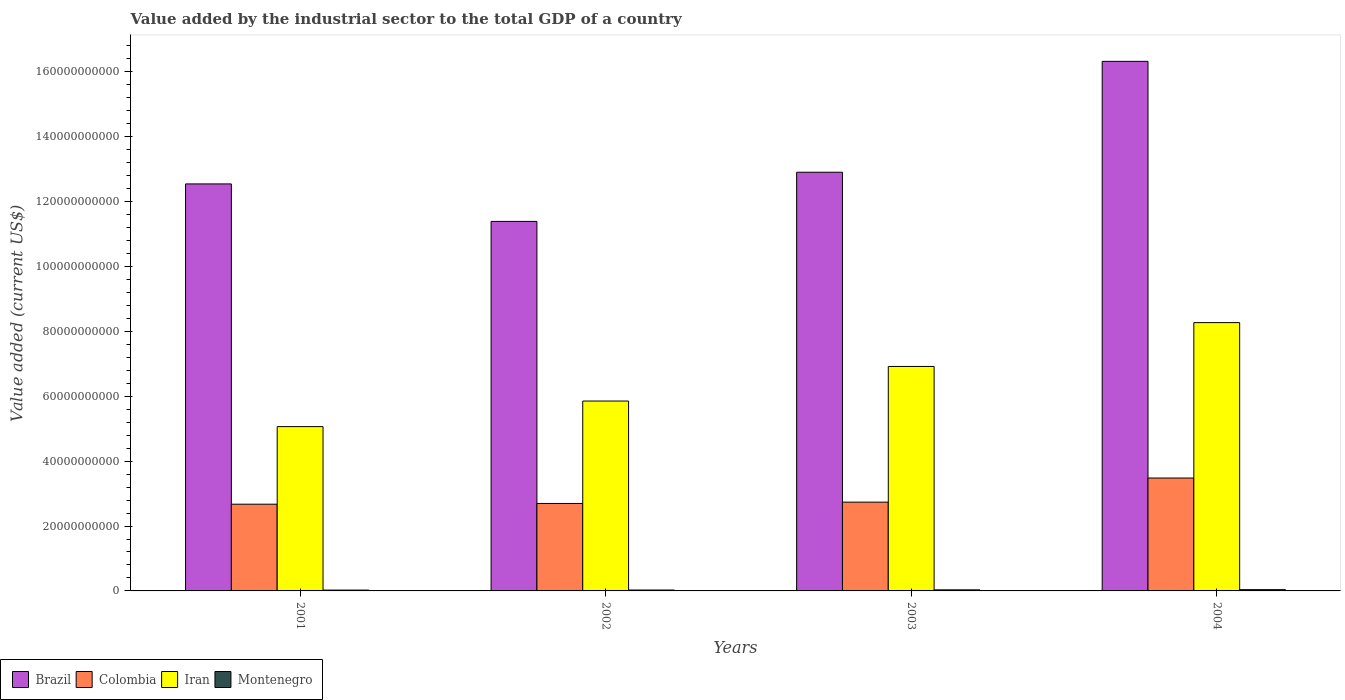How many different coloured bars are there?
Provide a short and direct response. 4. How many groups of bars are there?
Give a very brief answer. 4. Are the number of bars per tick equal to the number of legend labels?
Your answer should be compact. Yes. How many bars are there on the 1st tick from the left?
Give a very brief answer. 4. What is the label of the 3rd group of bars from the left?
Your answer should be very brief. 2003. What is the value added by the industrial sector to the total GDP in Iran in 2002?
Keep it short and to the point. 5.85e+1. Across all years, what is the maximum value added by the industrial sector to the total GDP in Montenegro?
Give a very brief answer. 3.93e+08. Across all years, what is the minimum value added by the industrial sector to the total GDP in Montenegro?
Give a very brief answer. 2.59e+08. In which year was the value added by the industrial sector to the total GDP in Montenegro maximum?
Your response must be concise. 2004. In which year was the value added by the industrial sector to the total GDP in Brazil minimum?
Your answer should be very brief. 2002. What is the total value added by the industrial sector to the total GDP in Colombia in the graph?
Offer a terse response. 1.16e+11. What is the difference between the value added by the industrial sector to the total GDP in Iran in 2001 and that in 2002?
Offer a very short reply. -7.88e+09. What is the difference between the value added by the industrial sector to the total GDP in Iran in 2003 and the value added by the industrial sector to the total GDP in Brazil in 2002?
Make the answer very short. -4.47e+1. What is the average value added by the industrial sector to the total GDP in Montenegro per year?
Your response must be concise. 3.15e+08. In the year 2004, what is the difference between the value added by the industrial sector to the total GDP in Montenegro and value added by the industrial sector to the total GDP in Colombia?
Your answer should be very brief. -3.44e+1. In how many years, is the value added by the industrial sector to the total GDP in Montenegro greater than 140000000000 US$?
Ensure brevity in your answer.  0. What is the ratio of the value added by the industrial sector to the total GDP in Colombia in 2001 to that in 2004?
Keep it short and to the point. 0.77. Is the difference between the value added by the industrial sector to the total GDP in Montenegro in 2001 and 2002 greater than the difference between the value added by the industrial sector to the total GDP in Colombia in 2001 and 2002?
Your response must be concise. Yes. What is the difference between the highest and the second highest value added by the industrial sector to the total GDP in Iran?
Provide a short and direct response. 1.35e+1. What is the difference between the highest and the lowest value added by the industrial sector to the total GDP in Colombia?
Offer a very short reply. 8.07e+09. In how many years, is the value added by the industrial sector to the total GDP in Montenegro greater than the average value added by the industrial sector to the total GDP in Montenegro taken over all years?
Provide a short and direct response. 2. What does the 2nd bar from the left in 2004 represents?
Keep it short and to the point. Colombia. What does the 2nd bar from the right in 2003 represents?
Your answer should be compact. Iran. Is it the case that in every year, the sum of the value added by the industrial sector to the total GDP in Iran and value added by the industrial sector to the total GDP in Colombia is greater than the value added by the industrial sector to the total GDP in Montenegro?
Ensure brevity in your answer.  Yes. How many bars are there?
Offer a terse response. 16. Are all the bars in the graph horizontal?
Provide a short and direct response. No. How many legend labels are there?
Your answer should be compact. 4. How are the legend labels stacked?
Ensure brevity in your answer.  Horizontal. What is the title of the graph?
Your response must be concise. Value added by the industrial sector to the total GDP of a country. Does "Marshall Islands" appear as one of the legend labels in the graph?
Offer a terse response. No. What is the label or title of the X-axis?
Your response must be concise. Years. What is the label or title of the Y-axis?
Provide a short and direct response. Value added (current US$). What is the Value added (current US$) in Brazil in 2001?
Provide a short and direct response. 1.25e+11. What is the Value added (current US$) in Colombia in 2001?
Offer a terse response. 2.67e+1. What is the Value added (current US$) of Iran in 2001?
Ensure brevity in your answer.  5.06e+1. What is the Value added (current US$) of Montenegro in 2001?
Offer a very short reply. 2.59e+08. What is the Value added (current US$) of Brazil in 2002?
Provide a succinct answer. 1.14e+11. What is the Value added (current US$) in Colombia in 2002?
Offer a very short reply. 2.70e+1. What is the Value added (current US$) in Iran in 2002?
Your answer should be very brief. 5.85e+1. What is the Value added (current US$) in Montenegro in 2002?
Provide a short and direct response. 2.77e+08. What is the Value added (current US$) in Brazil in 2003?
Give a very brief answer. 1.29e+11. What is the Value added (current US$) of Colombia in 2003?
Provide a short and direct response. 2.74e+1. What is the Value added (current US$) of Iran in 2003?
Provide a short and direct response. 6.92e+1. What is the Value added (current US$) in Montenegro in 2003?
Your response must be concise. 3.30e+08. What is the Value added (current US$) in Brazil in 2004?
Keep it short and to the point. 1.63e+11. What is the Value added (current US$) in Colombia in 2004?
Give a very brief answer. 3.48e+1. What is the Value added (current US$) in Iran in 2004?
Give a very brief answer. 8.27e+1. What is the Value added (current US$) in Montenegro in 2004?
Make the answer very short. 3.93e+08. Across all years, what is the maximum Value added (current US$) in Brazil?
Make the answer very short. 1.63e+11. Across all years, what is the maximum Value added (current US$) of Colombia?
Ensure brevity in your answer.  3.48e+1. Across all years, what is the maximum Value added (current US$) of Iran?
Offer a very short reply. 8.27e+1. Across all years, what is the maximum Value added (current US$) in Montenegro?
Your answer should be compact. 3.93e+08. Across all years, what is the minimum Value added (current US$) in Brazil?
Make the answer very short. 1.14e+11. Across all years, what is the minimum Value added (current US$) of Colombia?
Provide a succinct answer. 2.67e+1. Across all years, what is the minimum Value added (current US$) in Iran?
Provide a short and direct response. 5.06e+1. Across all years, what is the minimum Value added (current US$) in Montenegro?
Make the answer very short. 2.59e+08. What is the total Value added (current US$) of Brazil in the graph?
Provide a short and direct response. 5.32e+11. What is the total Value added (current US$) of Colombia in the graph?
Provide a succinct answer. 1.16e+11. What is the total Value added (current US$) in Iran in the graph?
Your answer should be compact. 2.61e+11. What is the total Value added (current US$) of Montenegro in the graph?
Ensure brevity in your answer.  1.26e+09. What is the difference between the Value added (current US$) of Brazil in 2001 and that in 2002?
Offer a very short reply. 1.16e+1. What is the difference between the Value added (current US$) of Colombia in 2001 and that in 2002?
Provide a short and direct response. -2.26e+08. What is the difference between the Value added (current US$) in Iran in 2001 and that in 2002?
Offer a terse response. -7.88e+09. What is the difference between the Value added (current US$) of Montenegro in 2001 and that in 2002?
Provide a short and direct response. -1.86e+07. What is the difference between the Value added (current US$) in Brazil in 2001 and that in 2003?
Provide a short and direct response. -3.60e+09. What is the difference between the Value added (current US$) of Colombia in 2001 and that in 2003?
Provide a succinct answer. -6.34e+08. What is the difference between the Value added (current US$) of Iran in 2001 and that in 2003?
Offer a terse response. -1.85e+1. What is the difference between the Value added (current US$) in Montenegro in 2001 and that in 2003?
Offer a terse response. -7.13e+07. What is the difference between the Value added (current US$) of Brazil in 2001 and that in 2004?
Provide a succinct answer. -3.78e+1. What is the difference between the Value added (current US$) of Colombia in 2001 and that in 2004?
Your response must be concise. -8.07e+09. What is the difference between the Value added (current US$) of Iran in 2001 and that in 2004?
Offer a very short reply. -3.21e+1. What is the difference between the Value added (current US$) of Montenegro in 2001 and that in 2004?
Offer a very short reply. -1.35e+08. What is the difference between the Value added (current US$) of Brazil in 2002 and that in 2003?
Provide a short and direct response. -1.52e+1. What is the difference between the Value added (current US$) of Colombia in 2002 and that in 2003?
Provide a short and direct response. -4.07e+08. What is the difference between the Value added (current US$) of Iran in 2002 and that in 2003?
Give a very brief answer. -1.07e+1. What is the difference between the Value added (current US$) in Montenegro in 2002 and that in 2003?
Offer a terse response. -5.26e+07. What is the difference between the Value added (current US$) in Brazil in 2002 and that in 2004?
Keep it short and to the point. -4.93e+1. What is the difference between the Value added (current US$) of Colombia in 2002 and that in 2004?
Ensure brevity in your answer.  -7.84e+09. What is the difference between the Value added (current US$) in Iran in 2002 and that in 2004?
Ensure brevity in your answer.  -2.42e+1. What is the difference between the Value added (current US$) of Montenegro in 2002 and that in 2004?
Provide a short and direct response. -1.16e+08. What is the difference between the Value added (current US$) in Brazil in 2003 and that in 2004?
Offer a terse response. -3.42e+1. What is the difference between the Value added (current US$) of Colombia in 2003 and that in 2004?
Give a very brief answer. -7.43e+09. What is the difference between the Value added (current US$) in Iran in 2003 and that in 2004?
Your answer should be compact. -1.35e+1. What is the difference between the Value added (current US$) of Montenegro in 2003 and that in 2004?
Your answer should be compact. -6.33e+07. What is the difference between the Value added (current US$) of Brazil in 2001 and the Value added (current US$) of Colombia in 2002?
Your answer should be very brief. 9.85e+1. What is the difference between the Value added (current US$) of Brazil in 2001 and the Value added (current US$) of Iran in 2002?
Make the answer very short. 6.69e+1. What is the difference between the Value added (current US$) in Brazil in 2001 and the Value added (current US$) in Montenegro in 2002?
Provide a short and direct response. 1.25e+11. What is the difference between the Value added (current US$) in Colombia in 2001 and the Value added (current US$) in Iran in 2002?
Keep it short and to the point. -3.18e+1. What is the difference between the Value added (current US$) in Colombia in 2001 and the Value added (current US$) in Montenegro in 2002?
Offer a very short reply. 2.65e+1. What is the difference between the Value added (current US$) of Iran in 2001 and the Value added (current US$) of Montenegro in 2002?
Offer a terse response. 5.04e+1. What is the difference between the Value added (current US$) of Brazil in 2001 and the Value added (current US$) of Colombia in 2003?
Offer a terse response. 9.81e+1. What is the difference between the Value added (current US$) in Brazil in 2001 and the Value added (current US$) in Iran in 2003?
Offer a terse response. 5.63e+1. What is the difference between the Value added (current US$) of Brazil in 2001 and the Value added (current US$) of Montenegro in 2003?
Offer a very short reply. 1.25e+11. What is the difference between the Value added (current US$) of Colombia in 2001 and the Value added (current US$) of Iran in 2003?
Keep it short and to the point. -4.25e+1. What is the difference between the Value added (current US$) in Colombia in 2001 and the Value added (current US$) in Montenegro in 2003?
Ensure brevity in your answer.  2.64e+1. What is the difference between the Value added (current US$) of Iran in 2001 and the Value added (current US$) of Montenegro in 2003?
Keep it short and to the point. 5.03e+1. What is the difference between the Value added (current US$) in Brazil in 2001 and the Value added (current US$) in Colombia in 2004?
Keep it short and to the point. 9.07e+1. What is the difference between the Value added (current US$) of Brazil in 2001 and the Value added (current US$) of Iran in 2004?
Your answer should be compact. 4.28e+1. What is the difference between the Value added (current US$) of Brazil in 2001 and the Value added (current US$) of Montenegro in 2004?
Provide a short and direct response. 1.25e+11. What is the difference between the Value added (current US$) of Colombia in 2001 and the Value added (current US$) of Iran in 2004?
Provide a short and direct response. -5.60e+1. What is the difference between the Value added (current US$) of Colombia in 2001 and the Value added (current US$) of Montenegro in 2004?
Ensure brevity in your answer.  2.63e+1. What is the difference between the Value added (current US$) of Iran in 2001 and the Value added (current US$) of Montenegro in 2004?
Offer a very short reply. 5.03e+1. What is the difference between the Value added (current US$) in Brazil in 2002 and the Value added (current US$) in Colombia in 2003?
Ensure brevity in your answer.  8.65e+1. What is the difference between the Value added (current US$) of Brazil in 2002 and the Value added (current US$) of Iran in 2003?
Provide a succinct answer. 4.47e+1. What is the difference between the Value added (current US$) of Brazil in 2002 and the Value added (current US$) of Montenegro in 2003?
Provide a succinct answer. 1.14e+11. What is the difference between the Value added (current US$) of Colombia in 2002 and the Value added (current US$) of Iran in 2003?
Offer a very short reply. -4.22e+1. What is the difference between the Value added (current US$) of Colombia in 2002 and the Value added (current US$) of Montenegro in 2003?
Make the answer very short. 2.66e+1. What is the difference between the Value added (current US$) of Iran in 2002 and the Value added (current US$) of Montenegro in 2003?
Your answer should be compact. 5.82e+1. What is the difference between the Value added (current US$) in Brazil in 2002 and the Value added (current US$) in Colombia in 2004?
Make the answer very short. 7.91e+1. What is the difference between the Value added (current US$) in Brazil in 2002 and the Value added (current US$) in Iran in 2004?
Your response must be concise. 3.12e+1. What is the difference between the Value added (current US$) of Brazil in 2002 and the Value added (current US$) of Montenegro in 2004?
Offer a very short reply. 1.14e+11. What is the difference between the Value added (current US$) of Colombia in 2002 and the Value added (current US$) of Iran in 2004?
Ensure brevity in your answer.  -5.57e+1. What is the difference between the Value added (current US$) in Colombia in 2002 and the Value added (current US$) in Montenegro in 2004?
Offer a terse response. 2.66e+1. What is the difference between the Value added (current US$) in Iran in 2002 and the Value added (current US$) in Montenegro in 2004?
Offer a very short reply. 5.81e+1. What is the difference between the Value added (current US$) in Brazil in 2003 and the Value added (current US$) in Colombia in 2004?
Provide a short and direct response. 9.43e+1. What is the difference between the Value added (current US$) of Brazil in 2003 and the Value added (current US$) of Iran in 2004?
Your answer should be very brief. 4.64e+1. What is the difference between the Value added (current US$) in Brazil in 2003 and the Value added (current US$) in Montenegro in 2004?
Ensure brevity in your answer.  1.29e+11. What is the difference between the Value added (current US$) of Colombia in 2003 and the Value added (current US$) of Iran in 2004?
Your response must be concise. -5.53e+1. What is the difference between the Value added (current US$) of Colombia in 2003 and the Value added (current US$) of Montenegro in 2004?
Make the answer very short. 2.70e+1. What is the difference between the Value added (current US$) of Iran in 2003 and the Value added (current US$) of Montenegro in 2004?
Keep it short and to the point. 6.88e+1. What is the average Value added (current US$) of Brazil per year?
Offer a terse response. 1.33e+11. What is the average Value added (current US$) of Colombia per year?
Provide a short and direct response. 2.90e+1. What is the average Value added (current US$) of Iran per year?
Your answer should be very brief. 6.53e+1. What is the average Value added (current US$) in Montenegro per year?
Your response must be concise. 3.15e+08. In the year 2001, what is the difference between the Value added (current US$) in Brazil and Value added (current US$) in Colombia?
Offer a very short reply. 9.87e+1. In the year 2001, what is the difference between the Value added (current US$) in Brazil and Value added (current US$) in Iran?
Offer a terse response. 7.48e+1. In the year 2001, what is the difference between the Value added (current US$) of Brazil and Value added (current US$) of Montenegro?
Your answer should be very brief. 1.25e+11. In the year 2001, what is the difference between the Value added (current US$) of Colombia and Value added (current US$) of Iran?
Provide a succinct answer. -2.39e+1. In the year 2001, what is the difference between the Value added (current US$) in Colombia and Value added (current US$) in Montenegro?
Your answer should be very brief. 2.65e+1. In the year 2001, what is the difference between the Value added (current US$) in Iran and Value added (current US$) in Montenegro?
Offer a terse response. 5.04e+1. In the year 2002, what is the difference between the Value added (current US$) in Brazil and Value added (current US$) in Colombia?
Provide a succinct answer. 8.69e+1. In the year 2002, what is the difference between the Value added (current US$) in Brazil and Value added (current US$) in Iran?
Ensure brevity in your answer.  5.54e+1. In the year 2002, what is the difference between the Value added (current US$) in Brazil and Value added (current US$) in Montenegro?
Provide a short and direct response. 1.14e+11. In the year 2002, what is the difference between the Value added (current US$) of Colombia and Value added (current US$) of Iran?
Offer a very short reply. -3.16e+1. In the year 2002, what is the difference between the Value added (current US$) in Colombia and Value added (current US$) in Montenegro?
Provide a short and direct response. 2.67e+1. In the year 2002, what is the difference between the Value added (current US$) of Iran and Value added (current US$) of Montenegro?
Ensure brevity in your answer.  5.83e+1. In the year 2003, what is the difference between the Value added (current US$) of Brazil and Value added (current US$) of Colombia?
Give a very brief answer. 1.02e+11. In the year 2003, what is the difference between the Value added (current US$) in Brazil and Value added (current US$) in Iran?
Keep it short and to the point. 5.99e+1. In the year 2003, what is the difference between the Value added (current US$) of Brazil and Value added (current US$) of Montenegro?
Keep it short and to the point. 1.29e+11. In the year 2003, what is the difference between the Value added (current US$) of Colombia and Value added (current US$) of Iran?
Make the answer very short. -4.18e+1. In the year 2003, what is the difference between the Value added (current US$) in Colombia and Value added (current US$) in Montenegro?
Your answer should be compact. 2.70e+1. In the year 2003, what is the difference between the Value added (current US$) in Iran and Value added (current US$) in Montenegro?
Ensure brevity in your answer.  6.89e+1. In the year 2004, what is the difference between the Value added (current US$) of Brazil and Value added (current US$) of Colombia?
Your answer should be very brief. 1.28e+11. In the year 2004, what is the difference between the Value added (current US$) of Brazil and Value added (current US$) of Iran?
Offer a terse response. 8.05e+1. In the year 2004, what is the difference between the Value added (current US$) of Brazil and Value added (current US$) of Montenegro?
Keep it short and to the point. 1.63e+11. In the year 2004, what is the difference between the Value added (current US$) in Colombia and Value added (current US$) in Iran?
Give a very brief answer. -4.79e+1. In the year 2004, what is the difference between the Value added (current US$) in Colombia and Value added (current US$) in Montenegro?
Keep it short and to the point. 3.44e+1. In the year 2004, what is the difference between the Value added (current US$) in Iran and Value added (current US$) in Montenegro?
Your answer should be very brief. 8.23e+1. What is the ratio of the Value added (current US$) of Brazil in 2001 to that in 2002?
Give a very brief answer. 1.1. What is the ratio of the Value added (current US$) in Iran in 2001 to that in 2002?
Keep it short and to the point. 0.87. What is the ratio of the Value added (current US$) of Montenegro in 2001 to that in 2002?
Provide a short and direct response. 0.93. What is the ratio of the Value added (current US$) in Brazil in 2001 to that in 2003?
Your response must be concise. 0.97. What is the ratio of the Value added (current US$) in Colombia in 2001 to that in 2003?
Your response must be concise. 0.98. What is the ratio of the Value added (current US$) of Iran in 2001 to that in 2003?
Keep it short and to the point. 0.73. What is the ratio of the Value added (current US$) in Montenegro in 2001 to that in 2003?
Your answer should be very brief. 0.78. What is the ratio of the Value added (current US$) of Brazil in 2001 to that in 2004?
Give a very brief answer. 0.77. What is the ratio of the Value added (current US$) in Colombia in 2001 to that in 2004?
Your answer should be very brief. 0.77. What is the ratio of the Value added (current US$) of Iran in 2001 to that in 2004?
Make the answer very short. 0.61. What is the ratio of the Value added (current US$) in Montenegro in 2001 to that in 2004?
Ensure brevity in your answer.  0.66. What is the ratio of the Value added (current US$) in Brazil in 2002 to that in 2003?
Your answer should be very brief. 0.88. What is the ratio of the Value added (current US$) of Colombia in 2002 to that in 2003?
Your answer should be compact. 0.99. What is the ratio of the Value added (current US$) of Iran in 2002 to that in 2003?
Make the answer very short. 0.85. What is the ratio of the Value added (current US$) in Montenegro in 2002 to that in 2003?
Offer a terse response. 0.84. What is the ratio of the Value added (current US$) of Brazil in 2002 to that in 2004?
Your answer should be compact. 0.7. What is the ratio of the Value added (current US$) of Colombia in 2002 to that in 2004?
Ensure brevity in your answer.  0.77. What is the ratio of the Value added (current US$) in Iran in 2002 to that in 2004?
Provide a succinct answer. 0.71. What is the ratio of the Value added (current US$) in Montenegro in 2002 to that in 2004?
Your answer should be compact. 0.71. What is the ratio of the Value added (current US$) in Brazil in 2003 to that in 2004?
Make the answer very short. 0.79. What is the ratio of the Value added (current US$) of Colombia in 2003 to that in 2004?
Your answer should be very brief. 0.79. What is the ratio of the Value added (current US$) in Iran in 2003 to that in 2004?
Your response must be concise. 0.84. What is the ratio of the Value added (current US$) of Montenegro in 2003 to that in 2004?
Provide a short and direct response. 0.84. What is the difference between the highest and the second highest Value added (current US$) in Brazil?
Offer a very short reply. 3.42e+1. What is the difference between the highest and the second highest Value added (current US$) in Colombia?
Your response must be concise. 7.43e+09. What is the difference between the highest and the second highest Value added (current US$) of Iran?
Offer a very short reply. 1.35e+1. What is the difference between the highest and the second highest Value added (current US$) in Montenegro?
Your answer should be compact. 6.33e+07. What is the difference between the highest and the lowest Value added (current US$) of Brazil?
Provide a succinct answer. 4.93e+1. What is the difference between the highest and the lowest Value added (current US$) in Colombia?
Give a very brief answer. 8.07e+09. What is the difference between the highest and the lowest Value added (current US$) in Iran?
Your answer should be compact. 3.21e+1. What is the difference between the highest and the lowest Value added (current US$) in Montenegro?
Provide a short and direct response. 1.35e+08. 